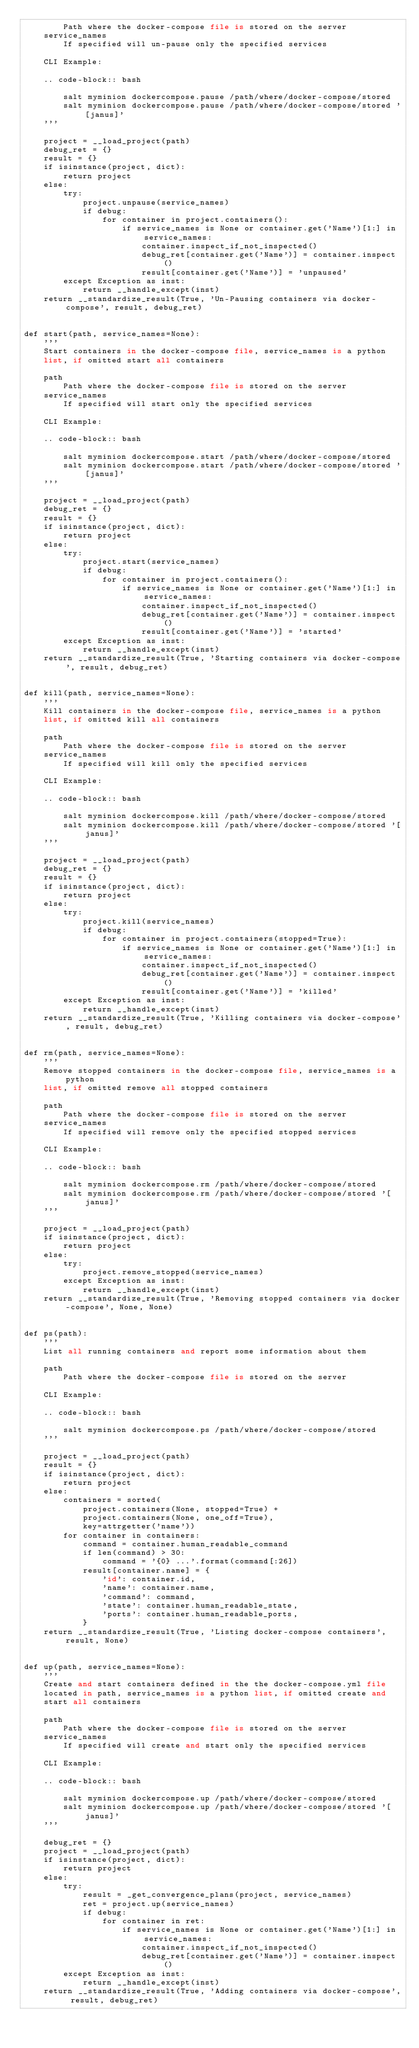Convert code to text. <code><loc_0><loc_0><loc_500><loc_500><_Python_>        Path where the docker-compose file is stored on the server
    service_names
        If specified will un-pause only the specified services

    CLI Example:

    .. code-block:: bash

        salt myminion dockercompose.pause /path/where/docker-compose/stored
        salt myminion dockercompose.pause /path/where/docker-compose/stored '[janus]'
    '''

    project = __load_project(path)
    debug_ret = {}
    result = {}
    if isinstance(project, dict):
        return project
    else:
        try:
            project.unpause(service_names)
            if debug:
                for container in project.containers():
                    if service_names is None or container.get('Name')[1:] in service_names:
                        container.inspect_if_not_inspected()
                        debug_ret[container.get('Name')] = container.inspect()
                        result[container.get('Name')] = 'unpaused'
        except Exception as inst:
            return __handle_except(inst)
    return __standardize_result(True, 'Un-Pausing containers via docker-compose', result, debug_ret)


def start(path, service_names=None):
    '''
    Start containers in the docker-compose file, service_names is a python
    list, if omitted start all containers

    path
        Path where the docker-compose file is stored on the server
    service_names
        If specified will start only the specified services

    CLI Example:

    .. code-block:: bash

        salt myminion dockercompose.start /path/where/docker-compose/stored
        salt myminion dockercompose.start /path/where/docker-compose/stored '[janus]'
    '''

    project = __load_project(path)
    debug_ret = {}
    result = {}
    if isinstance(project, dict):
        return project
    else:
        try:
            project.start(service_names)
            if debug:
                for container in project.containers():
                    if service_names is None or container.get('Name')[1:] in service_names:
                        container.inspect_if_not_inspected()
                        debug_ret[container.get('Name')] = container.inspect()
                        result[container.get('Name')] = 'started'
        except Exception as inst:
            return __handle_except(inst)
    return __standardize_result(True, 'Starting containers via docker-compose', result, debug_ret)


def kill(path, service_names=None):
    '''
    Kill containers in the docker-compose file, service_names is a python
    list, if omitted kill all containers

    path
        Path where the docker-compose file is stored on the server
    service_names
        If specified will kill only the specified services

    CLI Example:

    .. code-block:: bash

        salt myminion dockercompose.kill /path/where/docker-compose/stored
        salt myminion dockercompose.kill /path/where/docker-compose/stored '[janus]'
    '''

    project = __load_project(path)
    debug_ret = {}
    result = {}
    if isinstance(project, dict):
        return project
    else:
        try:
            project.kill(service_names)
            if debug:
                for container in project.containers(stopped=True):
                    if service_names is None or container.get('Name')[1:] in service_names:
                        container.inspect_if_not_inspected()
                        debug_ret[container.get('Name')] = container.inspect()
                        result[container.get('Name')] = 'killed'
        except Exception as inst:
            return __handle_except(inst)
    return __standardize_result(True, 'Killing containers via docker-compose', result, debug_ret)


def rm(path, service_names=None):
    '''
    Remove stopped containers in the docker-compose file, service_names is a python
    list, if omitted remove all stopped containers

    path
        Path where the docker-compose file is stored on the server
    service_names
        If specified will remove only the specified stopped services

    CLI Example:

    .. code-block:: bash

        salt myminion dockercompose.rm /path/where/docker-compose/stored
        salt myminion dockercompose.rm /path/where/docker-compose/stored '[janus]'
    '''

    project = __load_project(path)
    if isinstance(project, dict):
        return project
    else:
        try:
            project.remove_stopped(service_names)
        except Exception as inst:
            return __handle_except(inst)
    return __standardize_result(True, 'Removing stopped containers via docker-compose', None, None)


def ps(path):
    '''
    List all running containers and report some information about them

    path
        Path where the docker-compose file is stored on the server

    CLI Example:

    .. code-block:: bash

        salt myminion dockercompose.ps /path/where/docker-compose/stored
    '''

    project = __load_project(path)
    result = {}
    if isinstance(project, dict):
        return project
    else:
        containers = sorted(
            project.containers(None, stopped=True) +
            project.containers(None, one_off=True),
            key=attrgetter('name'))
        for container in containers:
            command = container.human_readable_command
            if len(command) > 30:
                command = '{0} ...'.format(command[:26])
            result[container.name] = {
                'id': container.id,
                'name': container.name,
                'command': command,
                'state': container.human_readable_state,
                'ports': container.human_readable_ports,
            }
    return __standardize_result(True, 'Listing docker-compose containers', result, None)


def up(path, service_names=None):
    '''
    Create and start containers defined in the the docker-compose.yml file
    located in path, service_names is a python list, if omitted create and
    start all containers

    path
        Path where the docker-compose file is stored on the server
    service_names
        If specified will create and start only the specified services

    CLI Example:

    .. code-block:: bash

        salt myminion dockercompose.up /path/where/docker-compose/stored
        salt myminion dockercompose.up /path/where/docker-compose/stored '[janus]'
    '''

    debug_ret = {}
    project = __load_project(path)
    if isinstance(project, dict):
        return project
    else:
        try:
            result = _get_convergence_plans(project, service_names)
            ret = project.up(service_names)
            if debug:
                for container in ret:
                    if service_names is None or container.get('Name')[1:] in service_names:
                        container.inspect_if_not_inspected()
                        debug_ret[container.get('Name')] = container.inspect()
        except Exception as inst:
            return __handle_except(inst)
    return __standardize_result(True, 'Adding containers via docker-compose', result, debug_ret)
</code> 